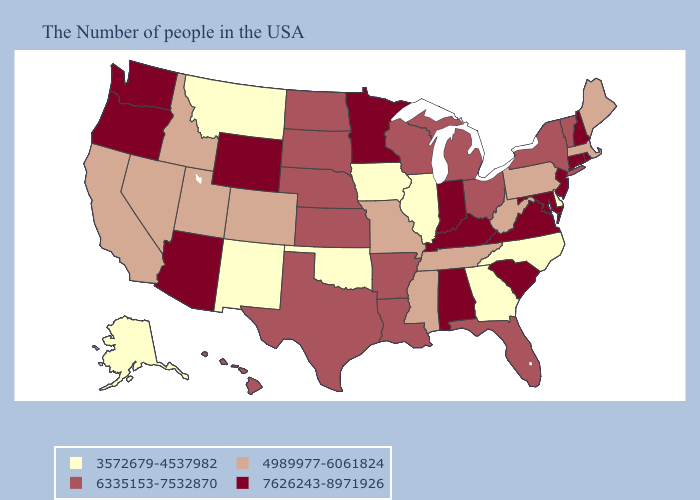Does the first symbol in the legend represent the smallest category?
Write a very short answer. Yes. Does Ohio have the highest value in the MidWest?
Quick response, please. No. Which states hav the highest value in the West?
Concise answer only. Wyoming, Arizona, Washington, Oregon. What is the value of Kentucky?
Quick response, please. 7626243-8971926. Does New Hampshire have the lowest value in the USA?
Quick response, please. No. What is the lowest value in the USA?
Give a very brief answer. 3572679-4537982. Name the states that have a value in the range 7626243-8971926?
Answer briefly. Rhode Island, New Hampshire, Connecticut, New Jersey, Maryland, Virginia, South Carolina, Kentucky, Indiana, Alabama, Minnesota, Wyoming, Arizona, Washington, Oregon. Does Delaware have a lower value than Iowa?
Concise answer only. No. Which states have the lowest value in the Northeast?
Short answer required. Maine, Massachusetts, Pennsylvania. What is the lowest value in the USA?
Keep it brief. 3572679-4537982. Name the states that have a value in the range 4989977-6061824?
Be succinct. Maine, Massachusetts, Pennsylvania, West Virginia, Tennessee, Mississippi, Missouri, Colorado, Utah, Idaho, Nevada, California. What is the lowest value in states that border South Dakota?
Answer briefly. 3572679-4537982. What is the value of Kansas?
Keep it brief. 6335153-7532870. How many symbols are there in the legend?
Keep it brief. 4. 